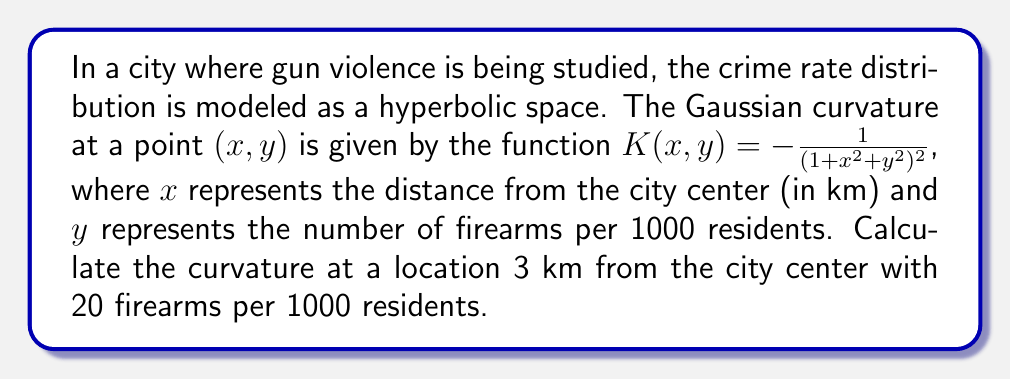Show me your answer to this math problem. To solve this problem, we'll follow these steps:

1) We're given the Gaussian curvature function for the hyperbolic space:

   $$K(x,y) = -\frac{1}{(1+x^2+y^2)^2}$$

2) We need to calculate the curvature at the point where:
   $x = 3$ (3 km from city center)
   $y = 20$ (20 firearms per 1000 residents)

3) Let's substitute these values into the curvature function:

   $$K(3,20) = -\frac{1}{(1+3^2+20^2)^2}$$

4) Simplify the expression inside the parentheses:
   $$1+3^2+20^2 = 1+9+400 = 410$$

5) Now our equation looks like:
   $$K(3,20) = -\frac{1}{(410)^2}$$

6) Calculate the square in the denominator:
   $$K(3,20) = -\frac{1}{168100}$$

7) This fraction can't be simplified further, so this is our final answer.
Answer: $-\frac{1}{168100}$ 